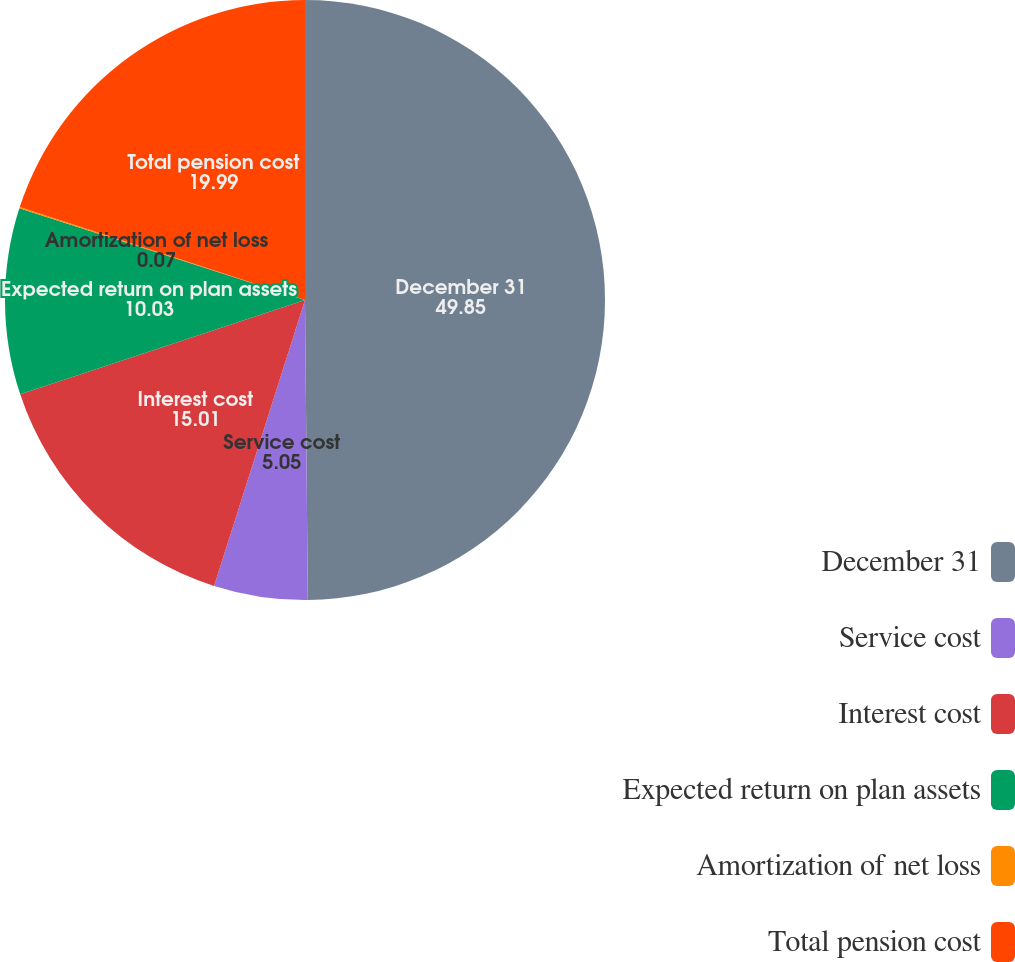Convert chart to OTSL. <chart><loc_0><loc_0><loc_500><loc_500><pie_chart><fcel>December 31<fcel>Service cost<fcel>Interest cost<fcel>Expected return on plan assets<fcel>Amortization of net loss<fcel>Total pension cost<nl><fcel>49.85%<fcel>5.05%<fcel>15.01%<fcel>10.03%<fcel>0.07%<fcel>19.99%<nl></chart> 